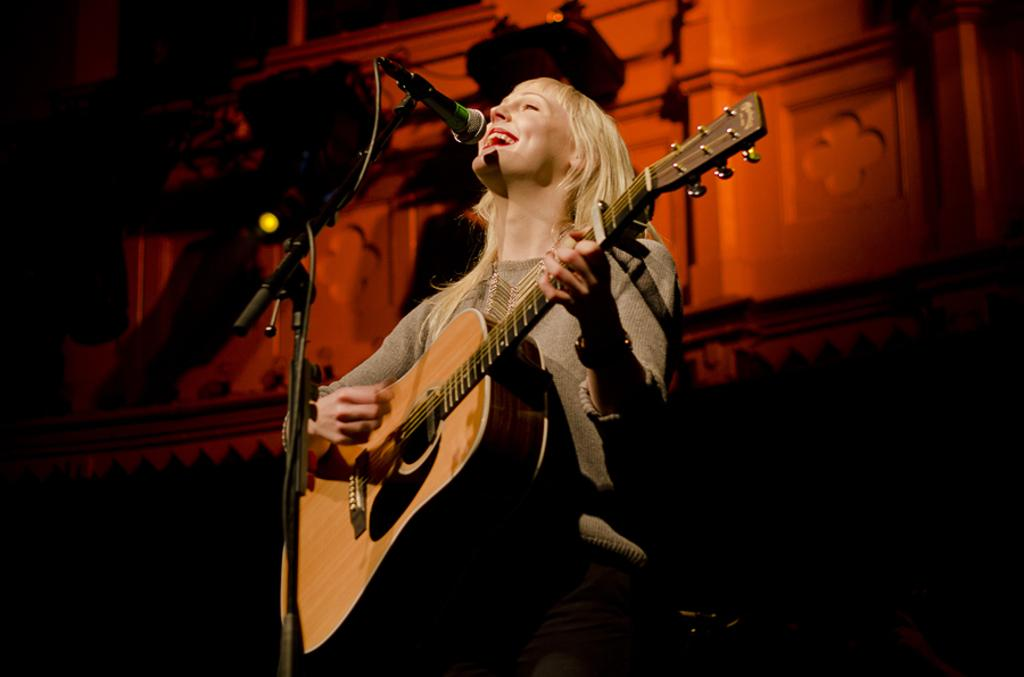What is the person in the image doing? The person in the image is playing a guitar. What object is present in the image that is commonly used for amplifying sound? There is a microphone in the image. Where is the monkey sitting while playing the guitar in the image? There is no monkey present in the image; it features a person playing a guitar. 